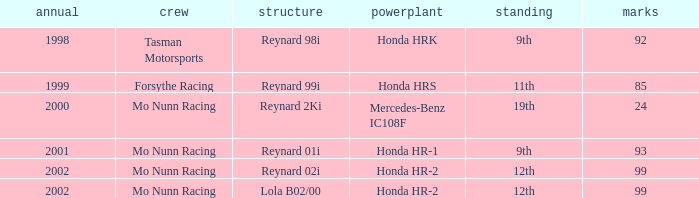What is the total number of points of the honda hr-1 engine? 1.0. 